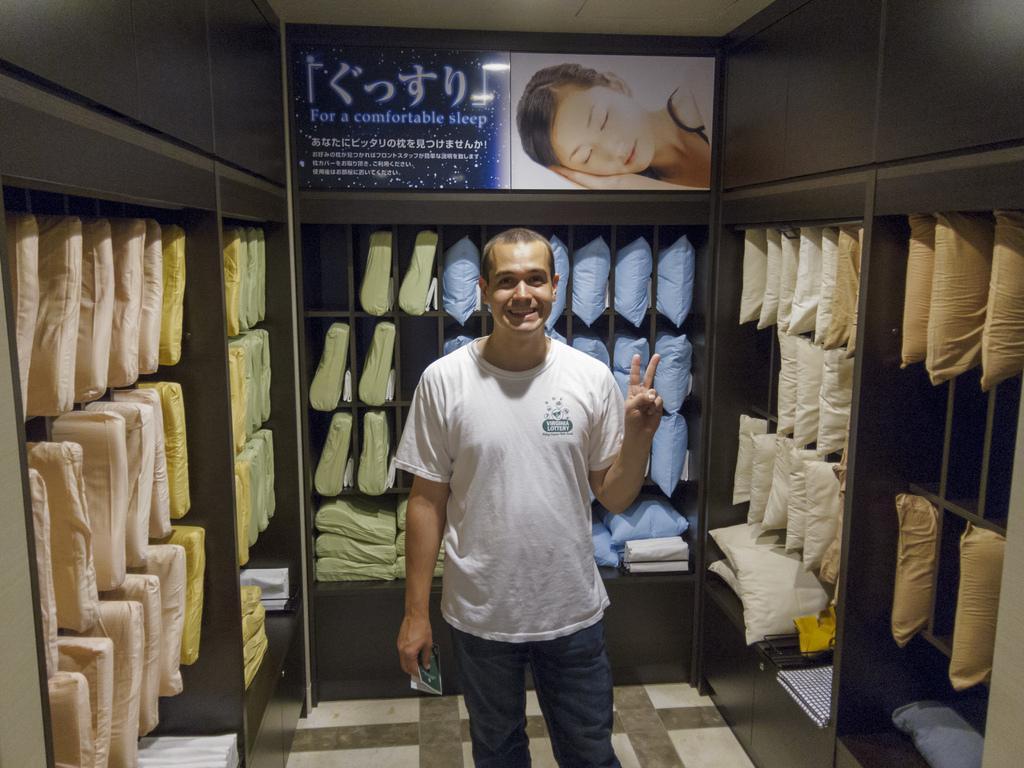How would you summarize this image in a sentence or two? In this image we can see a man standing on the floor, pillows arranged in rows in the cupboards and an advertisement at the top. 